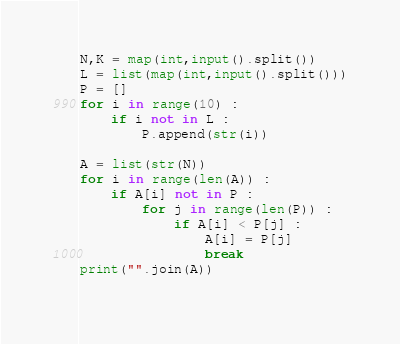Convert code to text. <code><loc_0><loc_0><loc_500><loc_500><_Python_>N,K = map(int,input().split())
L = list(map(int,input().split()))
P = []
for i in range(10) :
    if i not in L :
        P.append(str(i))

A = list(str(N))
for i in range(len(A)) :
    if A[i] not in P :
        for j in range(len(P)) :
            if A[i] < P[j] :
                A[i] = P[j]
                break
print("".join(A))
    </code> 